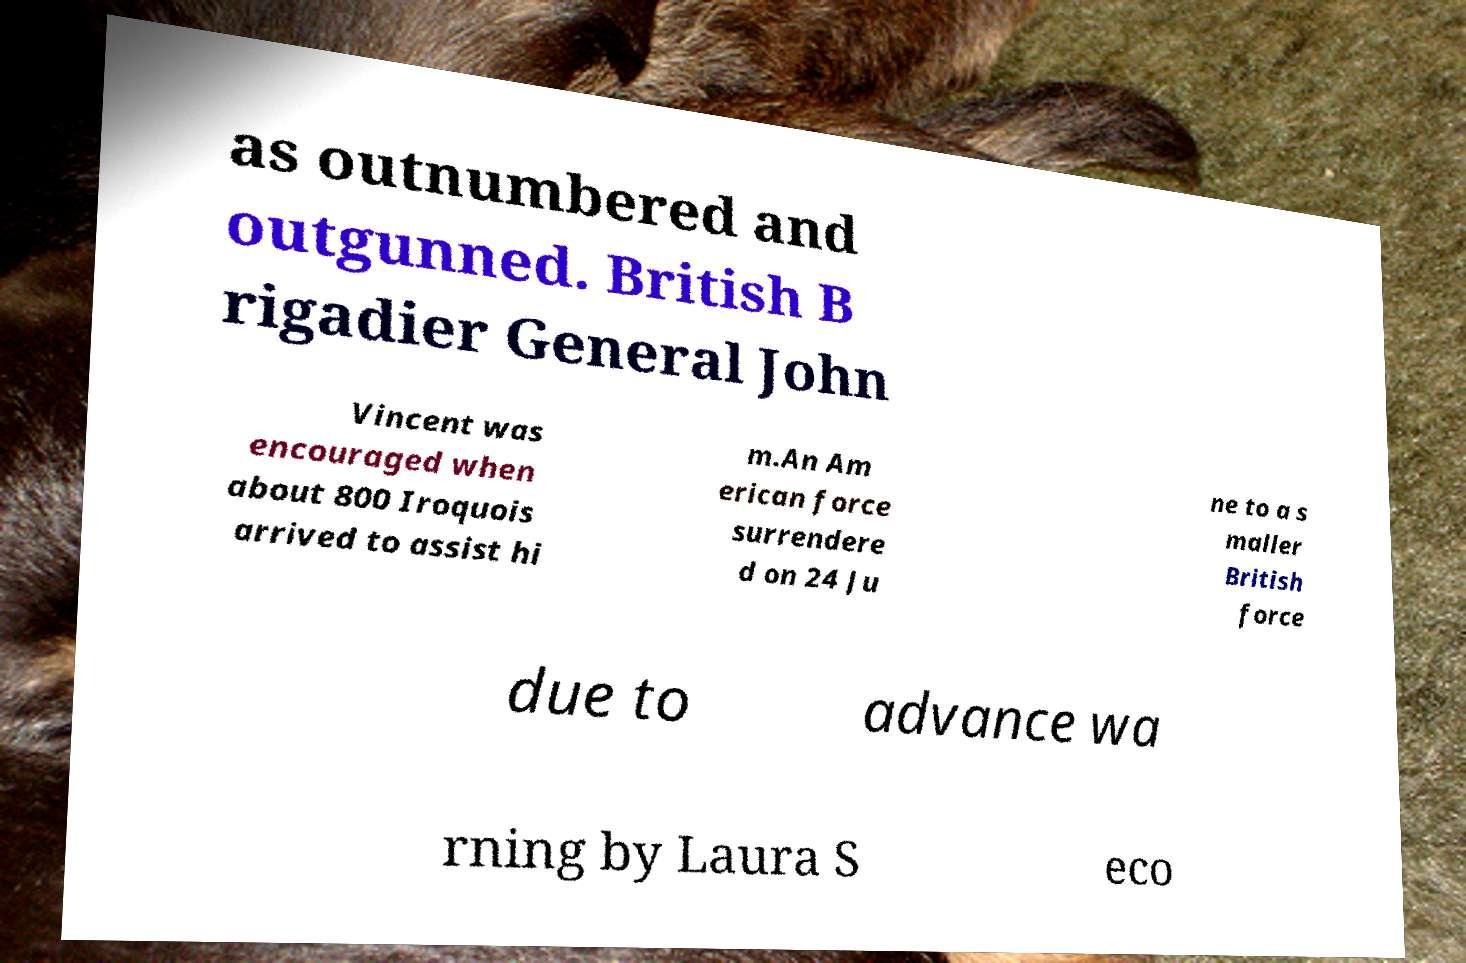Could you extract and type out the text from this image? as outnumbered and outgunned. British B rigadier General John Vincent was encouraged when about 800 Iroquois arrived to assist hi m.An Am erican force surrendere d on 24 Ju ne to a s maller British force due to advance wa rning by Laura S eco 